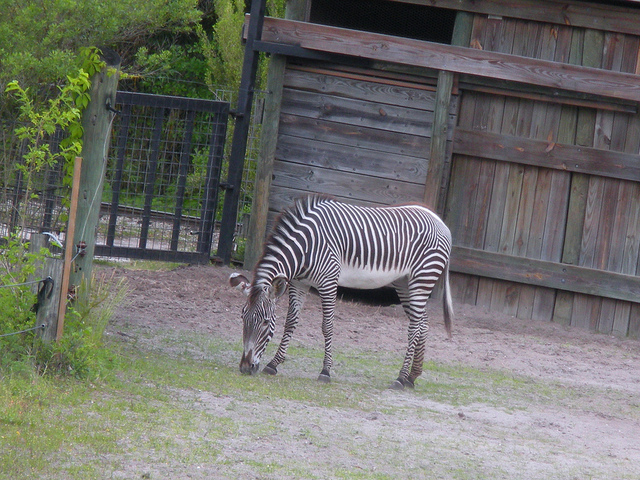<image>What is cast? It is ambiguous what is cast. It can be nothing, shadow, or sunlight. What is cast? I don't know what cast refers to in this context. It could be shadow or sunlight. 